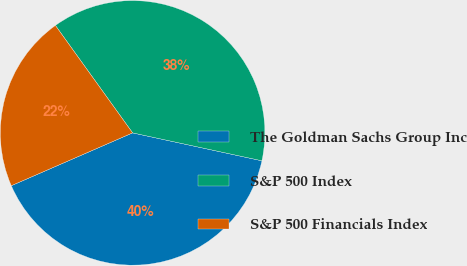<chart> <loc_0><loc_0><loc_500><loc_500><pie_chart><fcel>The Goldman Sachs Group Inc<fcel>S&P 500 Index<fcel>S&P 500 Financials Index<nl><fcel>40.08%<fcel>38.3%<fcel>21.62%<nl></chart> 